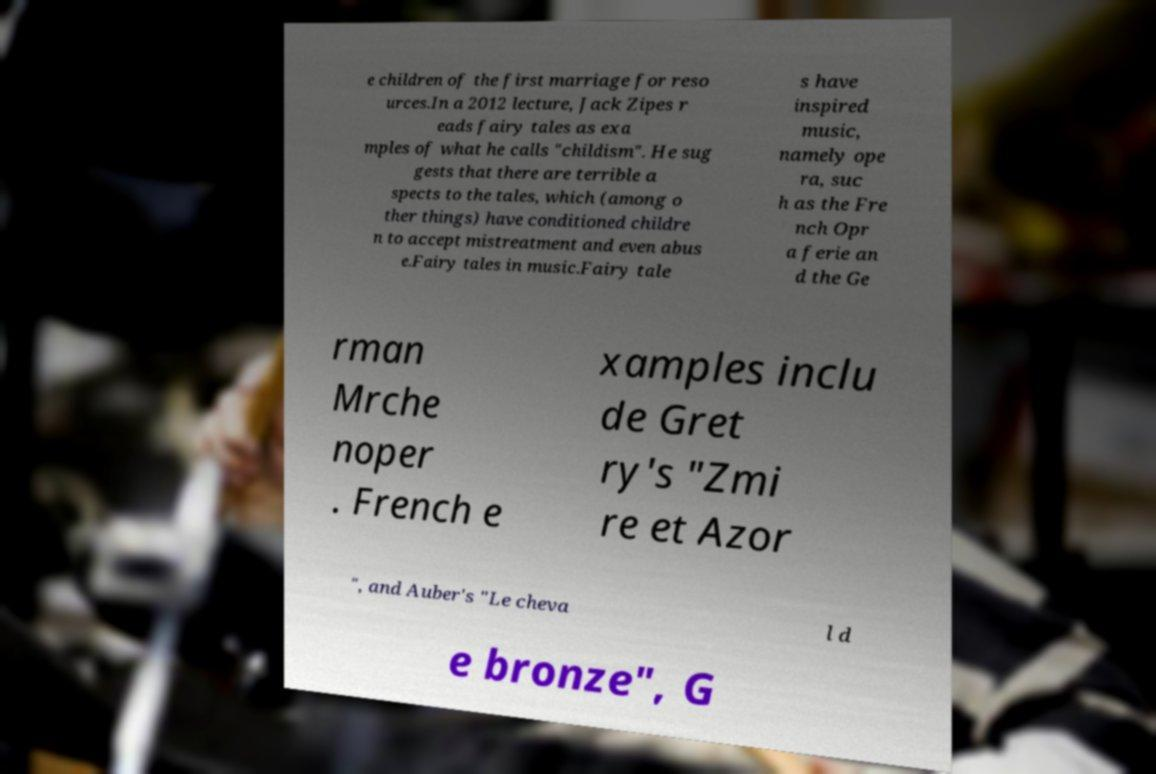What messages or text are displayed in this image? I need them in a readable, typed format. e children of the first marriage for reso urces.In a 2012 lecture, Jack Zipes r eads fairy tales as exa mples of what he calls "childism". He sug gests that there are terrible a spects to the tales, which (among o ther things) have conditioned childre n to accept mistreatment and even abus e.Fairy tales in music.Fairy tale s have inspired music, namely ope ra, suc h as the Fre nch Opr a ferie an d the Ge rman Mrche noper . French e xamples inclu de Gret ry's "Zmi re et Azor ", and Auber's "Le cheva l d e bronze", G 